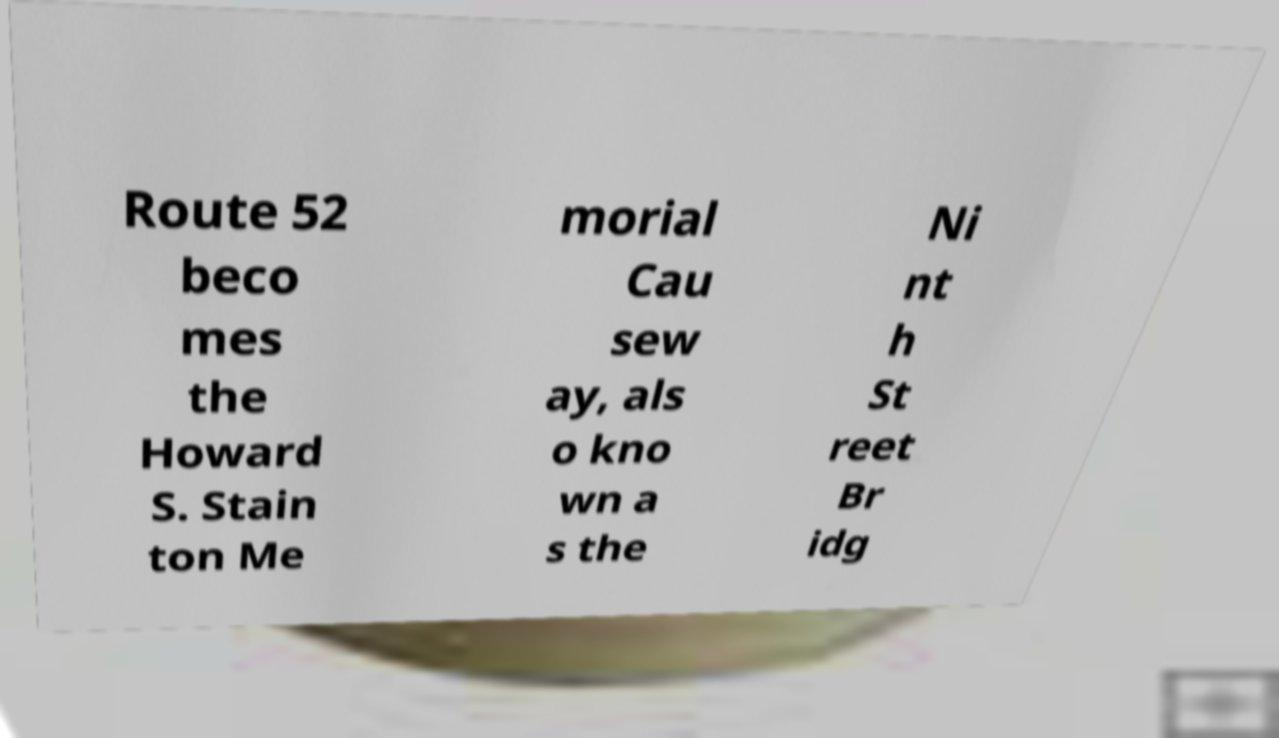Can you read and provide the text displayed in the image?This photo seems to have some interesting text. Can you extract and type it out for me? Route 52 beco mes the Howard S. Stain ton Me morial Cau sew ay, als o kno wn a s the Ni nt h St reet Br idg 